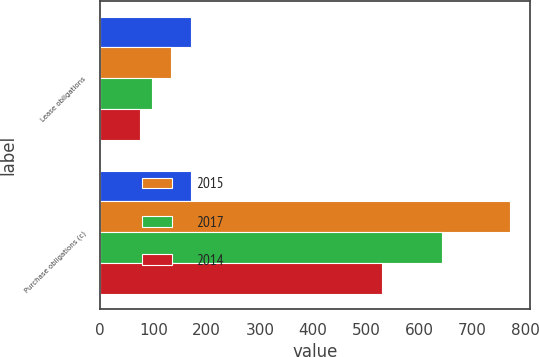Convert chart. <chart><loc_0><loc_0><loc_500><loc_500><stacked_bar_chart><ecel><fcel>Lease obligations<fcel>Purchase obligations (c)<nl><fcel>nan<fcel>171<fcel>171<nl><fcel>2015<fcel>133<fcel>770<nl><fcel>2017<fcel>97<fcel>642<nl><fcel>2014<fcel>74<fcel>529<nl></chart> 